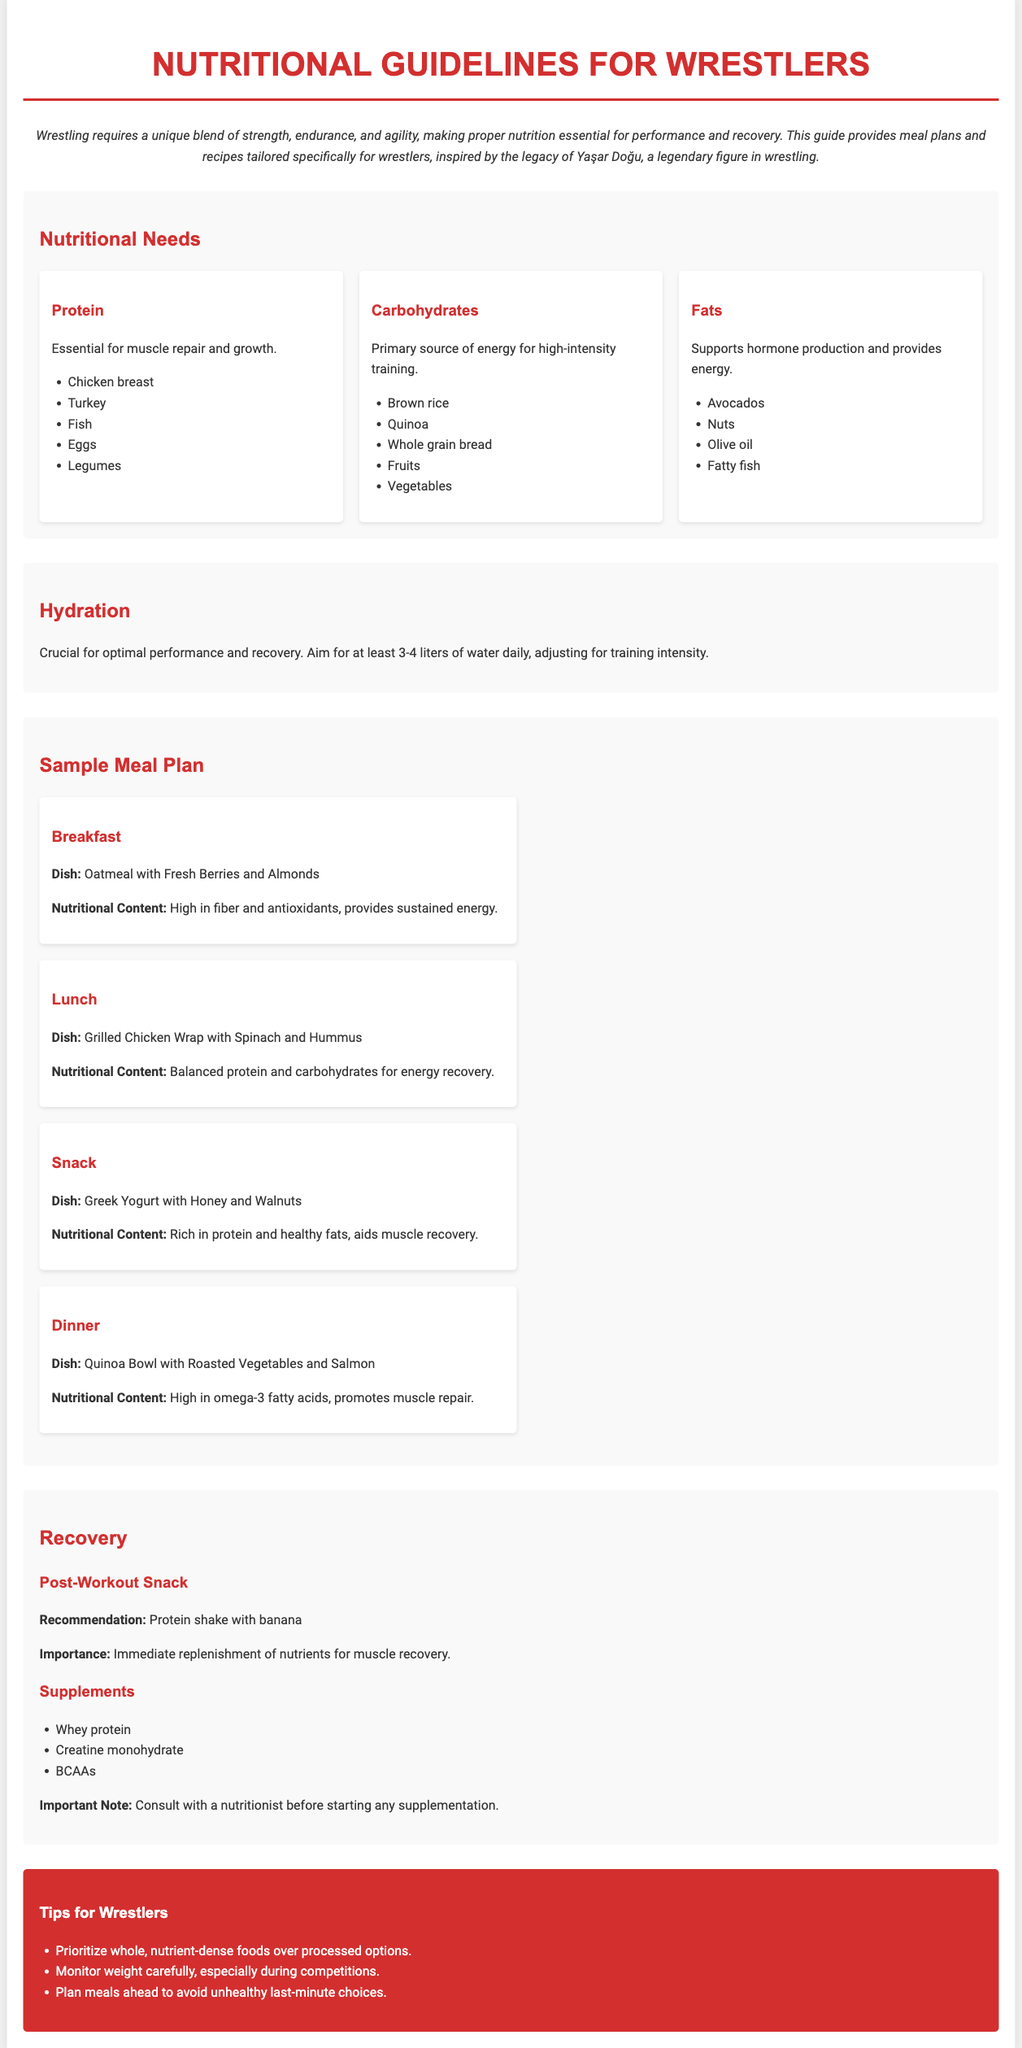What is the primary source of energy for high-intensity training? Carbohydrates are listed as the primary source of energy for high-intensity training in the nutritional guidelines.
Answer: Carbohydrates How much water should wrestlers aim to drink daily? The document states that wrestlers should aim for at least 3-4 liters of water daily.
Answer: 3-4 liters What dish is suggested for breakfast? The document provides a specific dish for breakfast as part of the sample meal plan.
Answer: Oatmeal with Fresh Berries and Almonds What is an important note regarding supplements? The document mentions a specific recommendation before starting any supplementation.
Answer: Consult with a nutritionist What do fats support in the body according to the guidelines? The document explains that fats are important for a specific physiological function.
Answer: Hormone production 